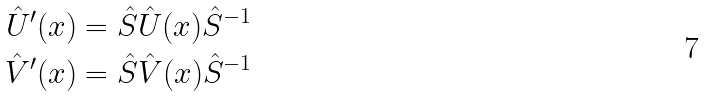<formula> <loc_0><loc_0><loc_500><loc_500>\hat { U } ^ { \prime } ( x ) & = \hat { S } \hat { U } ( x ) \hat { S } ^ { - 1 } \\ \hat { V } ^ { \prime } ( x ) & = \hat { S } \hat { V } ( x ) \hat { S } ^ { - 1 }</formula> 